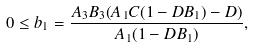<formula> <loc_0><loc_0><loc_500><loc_500>0 \leq b _ { 1 } = \frac { A _ { 3 } B _ { 3 } ( A _ { 1 } C ( 1 - D B _ { 1 } ) - D ) } { A _ { 1 } ( 1 - D B _ { 1 } ) } ,</formula> 